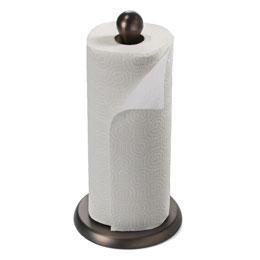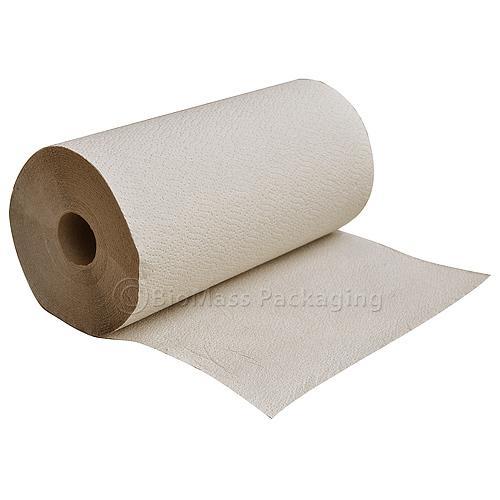The first image is the image on the left, the second image is the image on the right. Evaluate the accuracy of this statement regarding the images: "The left and right images contain the same number of rolls.". Is it true? Answer yes or no. Yes. 